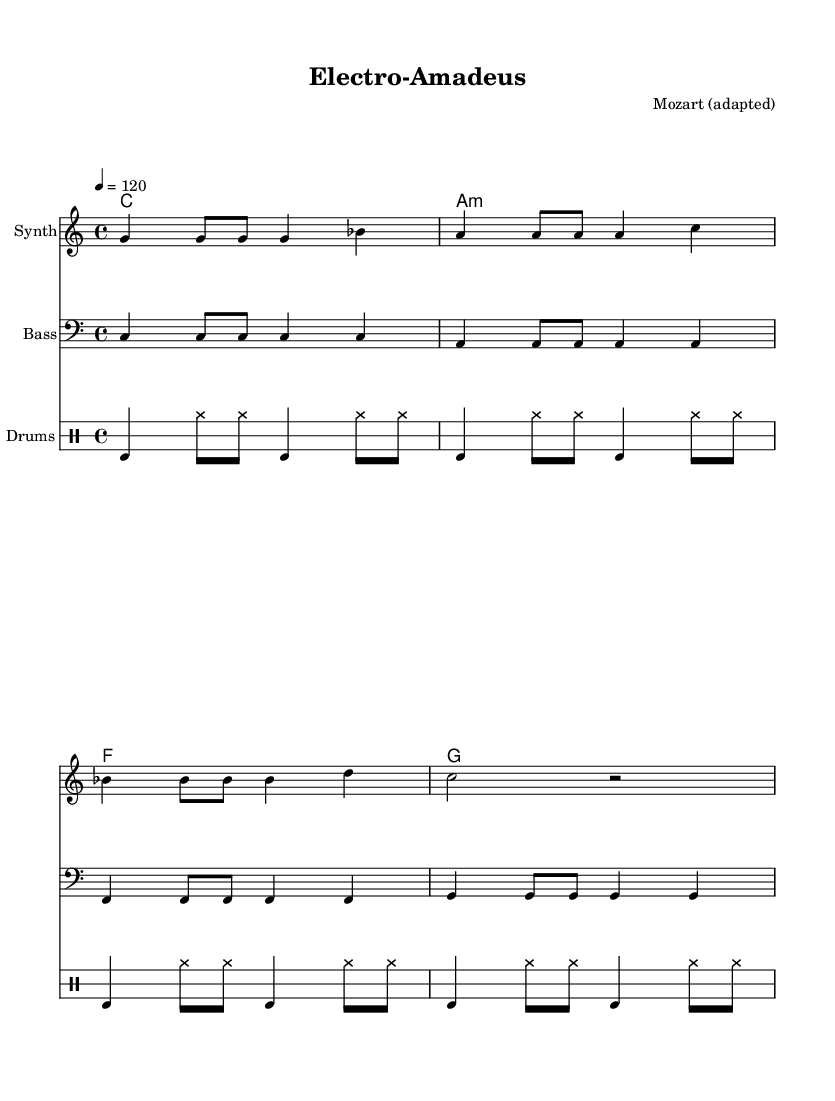What is the key signature of this music? The key signature indicates the absence of sharps and flats, which signifies that the music is in C major.
Answer: C major What is the time signature of this music? The time signature is indicated by the "4/4" at the beginning, meaning there are four beats in each measure.
Answer: 4/4 What is the tempo marking of this music? The tempo marking is 4 = 120, which indicates a speed of 120 beats per minute.
Answer: 120 How many measures are there in the melody? Counting the individual measures in the melody section shows there are 4 measures in total.
Answer: 4 What type of instruments are used in the score? The instruments listed include "Synth," "Bass," and "Drums," which indicate a fusion of electronic and traditional elements.
Answer: Synth, Bass, Drums What is the chord progression used in this piece? The chord progression is listed as C, A minor, F, G, which forms the harmonic basis for the piece.
Answer: C, A minor, F, G Why might this piece be considered a fusion of electronic and classical music? The piece combines classical melodies written by Mozart with contemporary electronic beats and instrumentation, creating a unique blend of styles.
Answer: Fusion of classical and electronic 